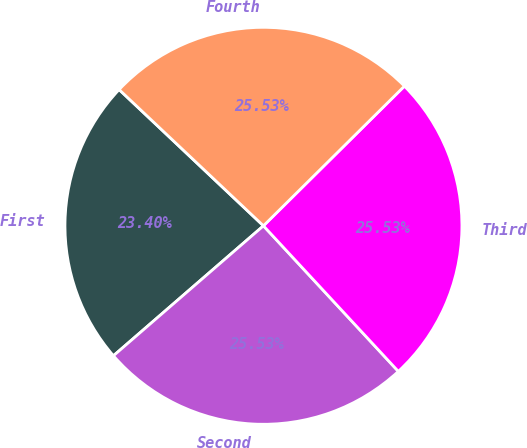Convert chart. <chart><loc_0><loc_0><loc_500><loc_500><pie_chart><fcel>First<fcel>Second<fcel>Third<fcel>Fourth<nl><fcel>23.4%<fcel>25.53%<fcel>25.53%<fcel>25.53%<nl></chart> 